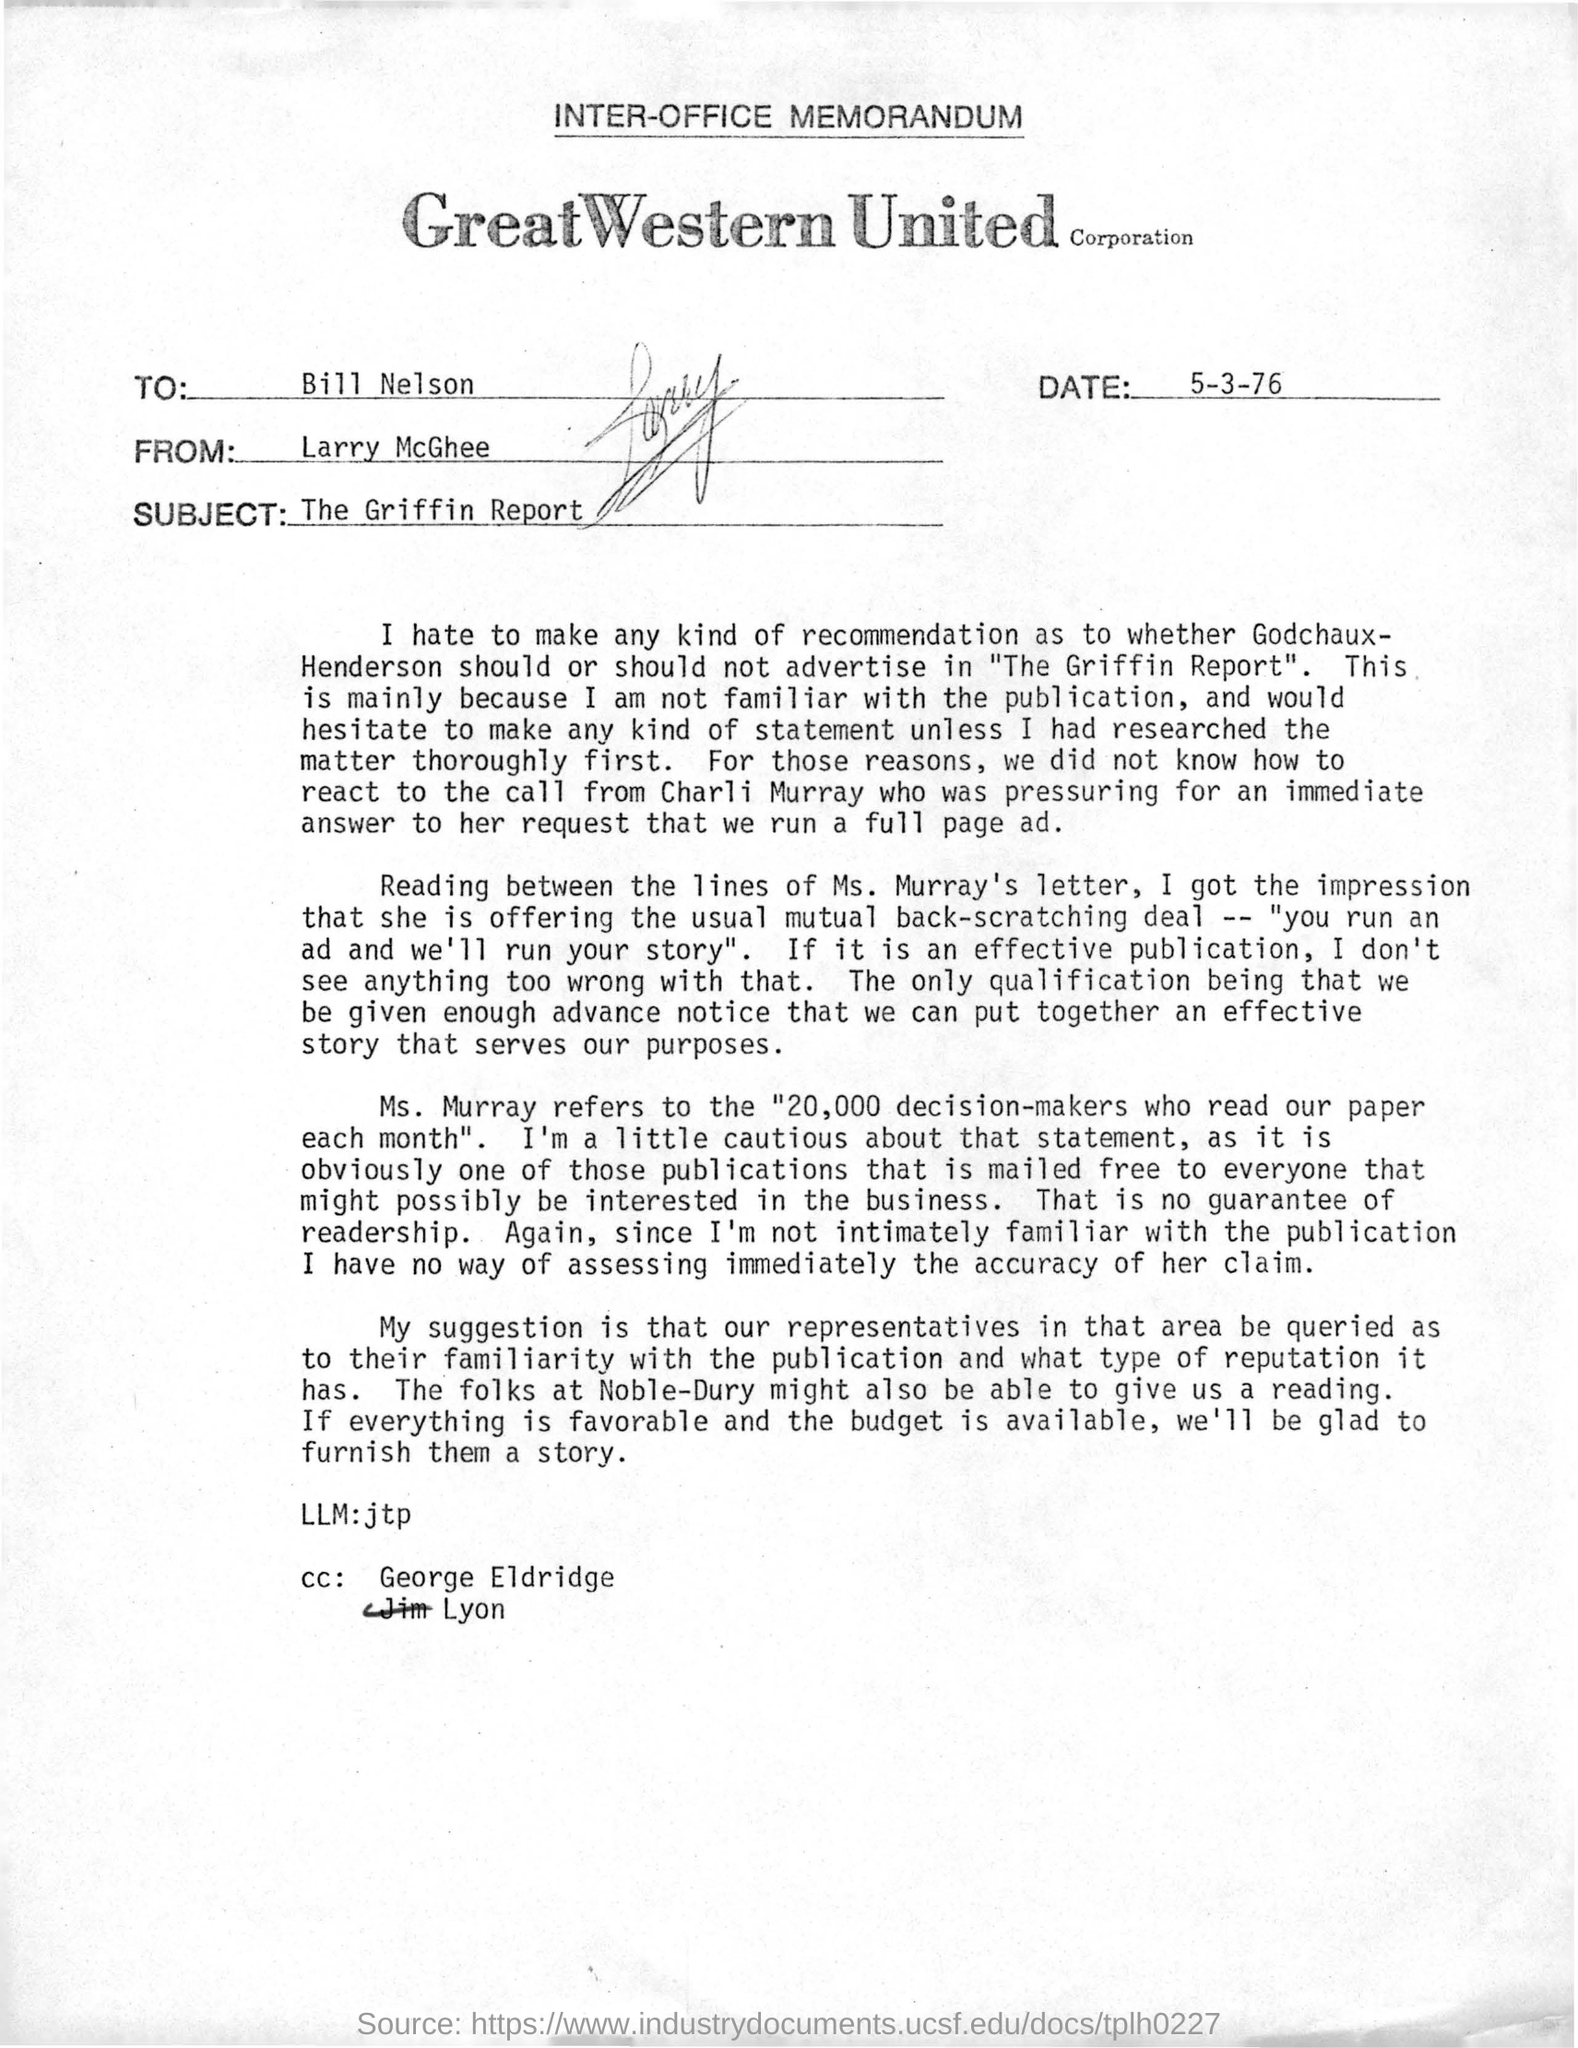What is the date mentioned in this memorandum?
Make the answer very short. 5-3-76. Who is the sender of this memorandum?
Your answer should be compact. Larry McGhee. Who is the receiver of the memorandum ?
Your answer should be compact. Bill Nelson. What is the subject of this memorandum?
Keep it short and to the point. The Griffin Report. 